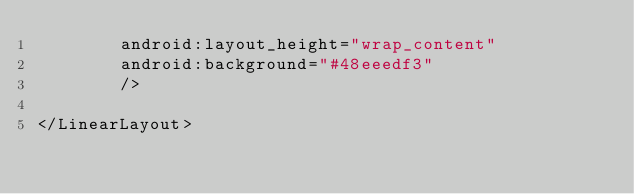<code> <loc_0><loc_0><loc_500><loc_500><_XML_>        android:layout_height="wrap_content"
        android:background="#48eeedf3"
        />
    
</LinearLayout> 
</code> 